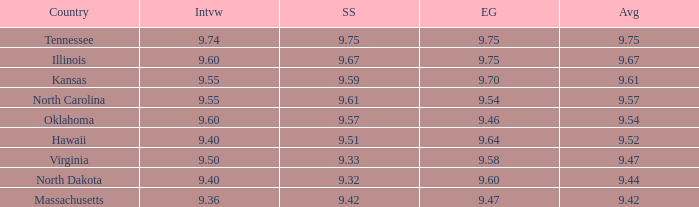Which country had an interview score of 9.40 and average of 9.44? North Dakota. 